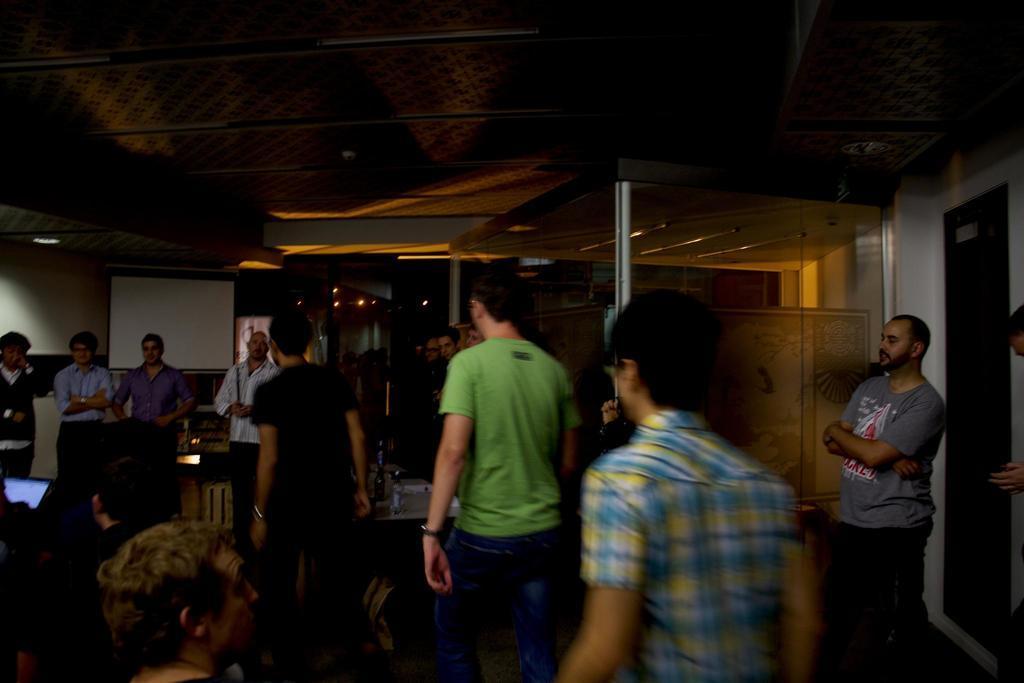Please provide a concise description of this image. In this image we can see group of persons walking on the floor. On the left side of the image we can see screen, person standing on the floor. On the right side of the image we can see person standing on the floor. In the background we can see wall and lights. 